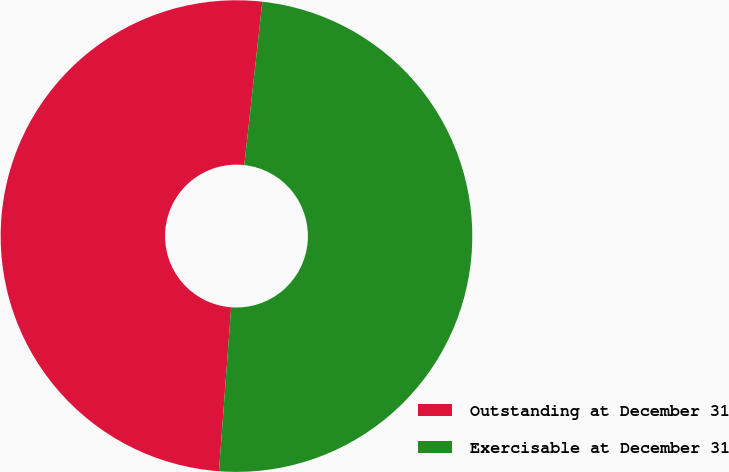Convert chart to OTSL. <chart><loc_0><loc_0><loc_500><loc_500><pie_chart><fcel>Outstanding at December 31<fcel>Exercisable at December 31<nl><fcel>50.57%<fcel>49.43%<nl></chart> 